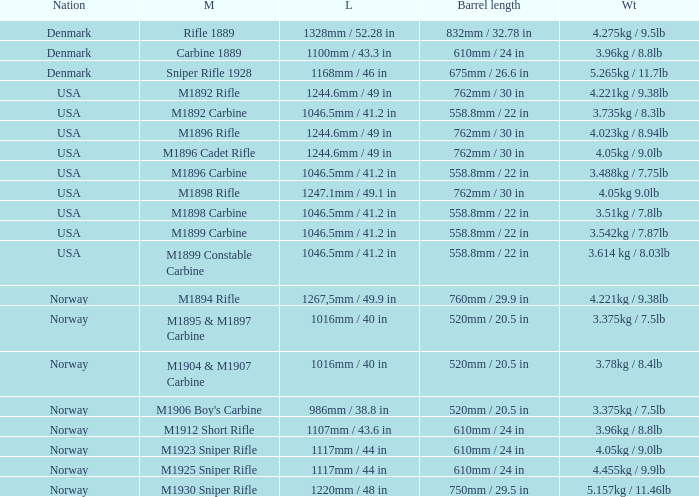What is Length, when Barrel Length is 750mm / 29.5 in? 1220mm / 48 in. 